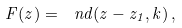Convert formula to latex. <formula><loc_0><loc_0><loc_500><loc_500>F ( z ) = \ n d ( z - z _ { 1 } , k ) \, ,</formula> 